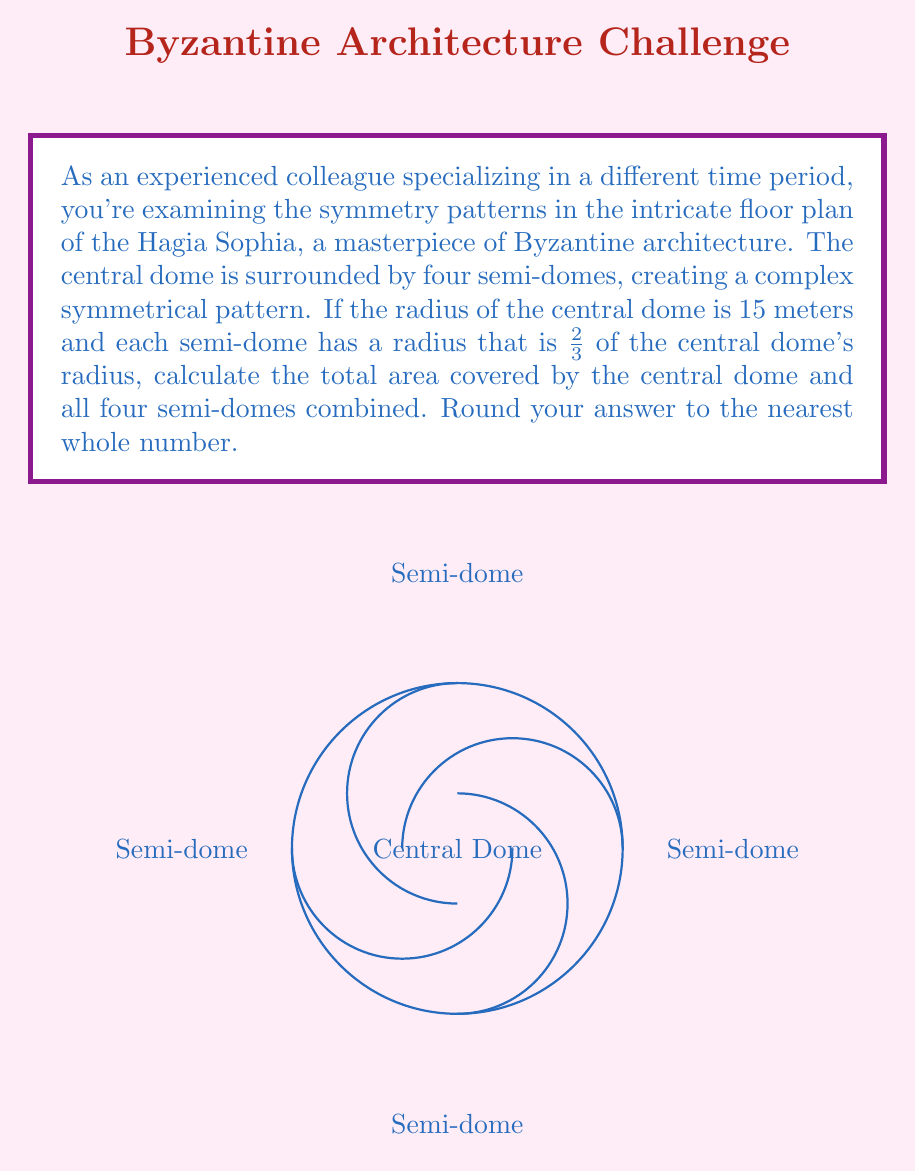Teach me how to tackle this problem. Let's approach this step-by-step:

1) First, let's calculate the radius of each semi-dome:
   $r_{semi} = \frac{2}{3} \times 15 = 10$ meters

2) Now, let's calculate the area of the central dome:
   $A_{central} = \pi r^2 = \pi \times 15^2 = 225\pi$ square meters

3) Next, we'll calculate the area of one semi-dome:
   The area of a full circle with radius 10 would be $\pi r^2 = 100\pi$
   A semi-dome is half of this, so: $A_{semi} = \frac{1}{2} \times 100\pi = 50\pi$ square meters

4) There are four semi-domes, so the total area of all semi-domes is:
   $A_{all\_semi} = 4 \times 50\pi = 200\pi$ square meters

5) Now, we can sum up the total area:
   $A_{total} = A_{central} + A_{all\_semi} = 225\pi + 200\pi = 425\pi$ square meters

6) Converting to a numerical value:
   $A_{total} = 425 \times 3.14159... \approx 1334.92$ square meters

7) Rounding to the nearest whole number:
   $A_{total} \approx 1335$ square meters
Answer: 1335 square meters 